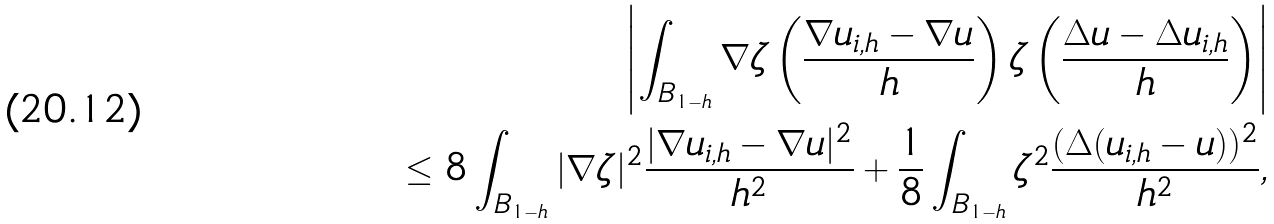<formula> <loc_0><loc_0><loc_500><loc_500>\left | \int _ { B _ { 1 - h } } \nabla \zeta \left ( \frac { \nabla u _ { i , h } - \nabla u } { h } \right ) \zeta \left ( \frac { \Delta u - \Delta u _ { i , h } } { h } \right ) \right | \\ \leq 8 \int _ { B _ { 1 - h } } | \nabla \zeta | ^ { 2 } \frac { | \nabla u _ { i , h } - \nabla u | ^ { 2 } } { h ^ { 2 } } + \frac { 1 } { 8 } \int _ { B _ { 1 - h } } \zeta ^ { 2 } \frac { ( \Delta ( u _ { i , h } - u ) ) ^ { 2 } } { h ^ { 2 } } ,</formula> 